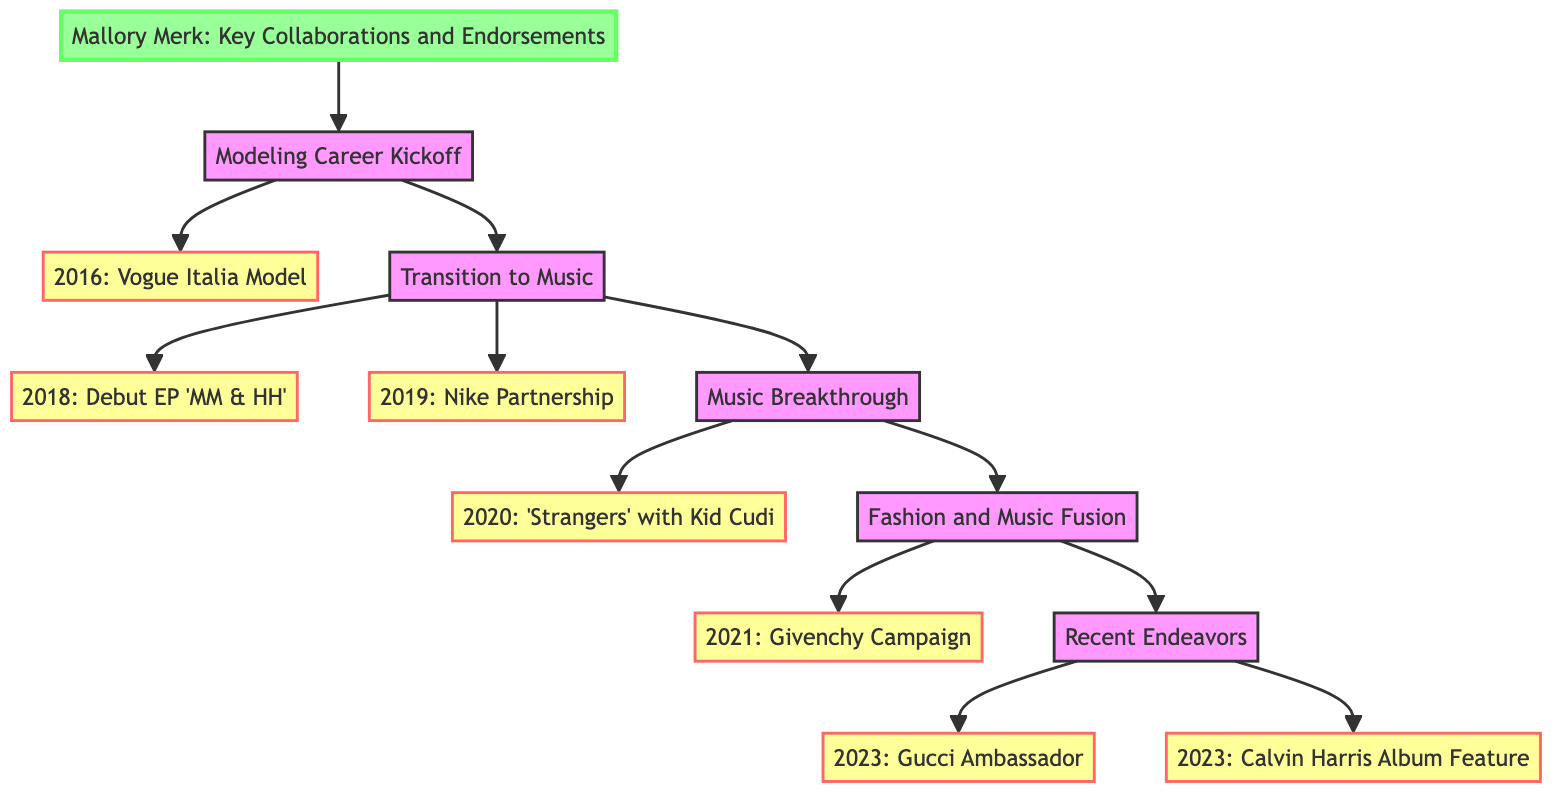What year did Mallory Merk begin modeling for Vogue Italia? The diagram indicates that the milestone for modeling for Vogue Italia is listed under the step titled "Modeling Career Kickoff." The specific year mentioned for this collaboration is 2016.
Answer: 2016 What collaboration did Mallory Merk have in 2020? In the "Music Breakthrough" step, the milestone for the year 2020 shows that Mallory Merk collaborated on the single "Strangers" produced by Kid Cudi.
Answer: Single 'Strangers' produced by Kid Cudi How many major collaborations were listed in the "Transition to Music" step? The "Transition to Music" step has two milestones: one for releasing her debut EP in 2018 and another for the Nike partnership in 2019, which counts as two collaborations.
Answer: 2 Which fashion brand did Mallory Merk collaborate with in 2021? Within the "Fashion and Music Fusion" step, it is noted that Mallory was the face of Givenchy's campaign in 2021.
Answer: Givenchy What was the endorsement Mallory Merk received in 2023? Under the "Recent Endeavors" section, the endorsement listed for 2023 is "Gucci," where she acts as an ambassador for their new collection.
Answer: Gucci Is there a collaboration with Calvin Harris mentioned in the diagram? Yes, the "Recent Endeavors" step includes a milestone indicating that Mallory Merk contributed vocals as a featured artist in Calvin Harris's album in 2023.
Answer: Yes What step follows the "Modeling Career Kickoff" in the diagram? The next step listed after "Modeling Career Kickoff" is "Transition to Music," indicating the progression of her career.
Answer: Transition to Music How many total endorsements are mentioned in the entire clinical pathway? From reviewing all the steps in the diagram, the endorsements mentioned include Nike in 2019 and Gucci in 2023, which totals two endorsements.
Answer: 2 